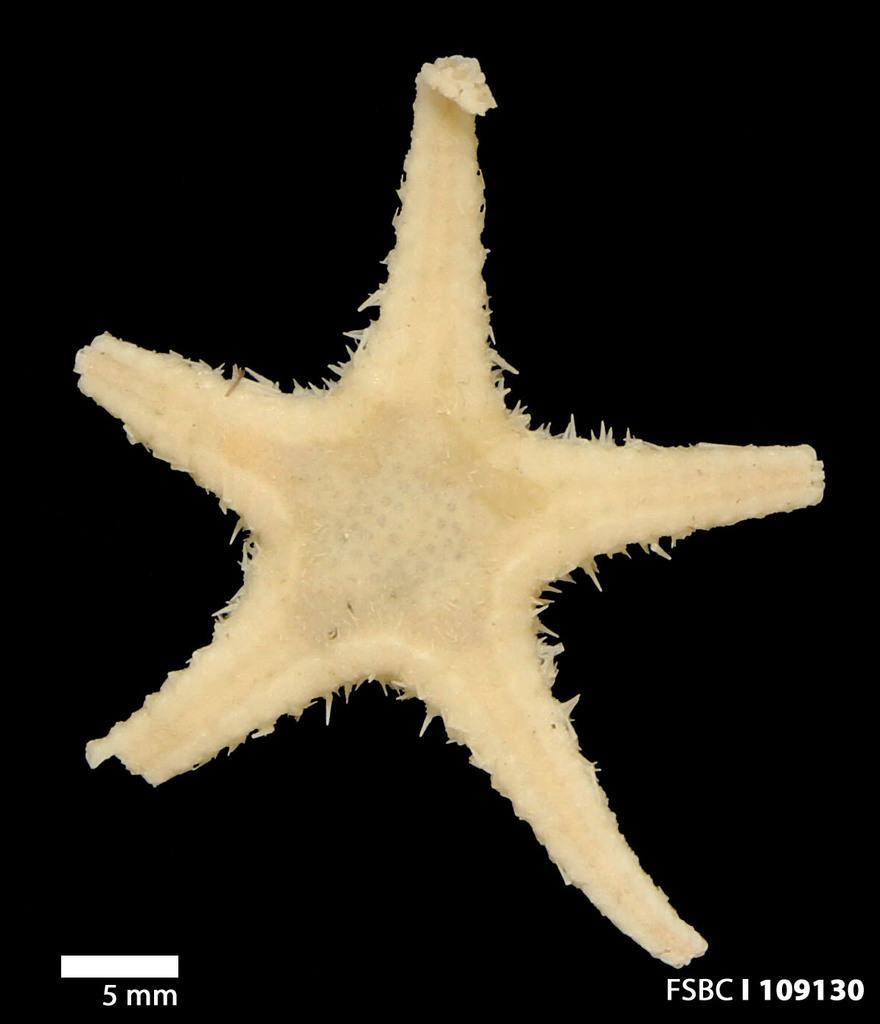Please provide a concise description of this image. In this image the background is dark. In the middle of the image there is a starfish. At the bottom of the image there is a text. 